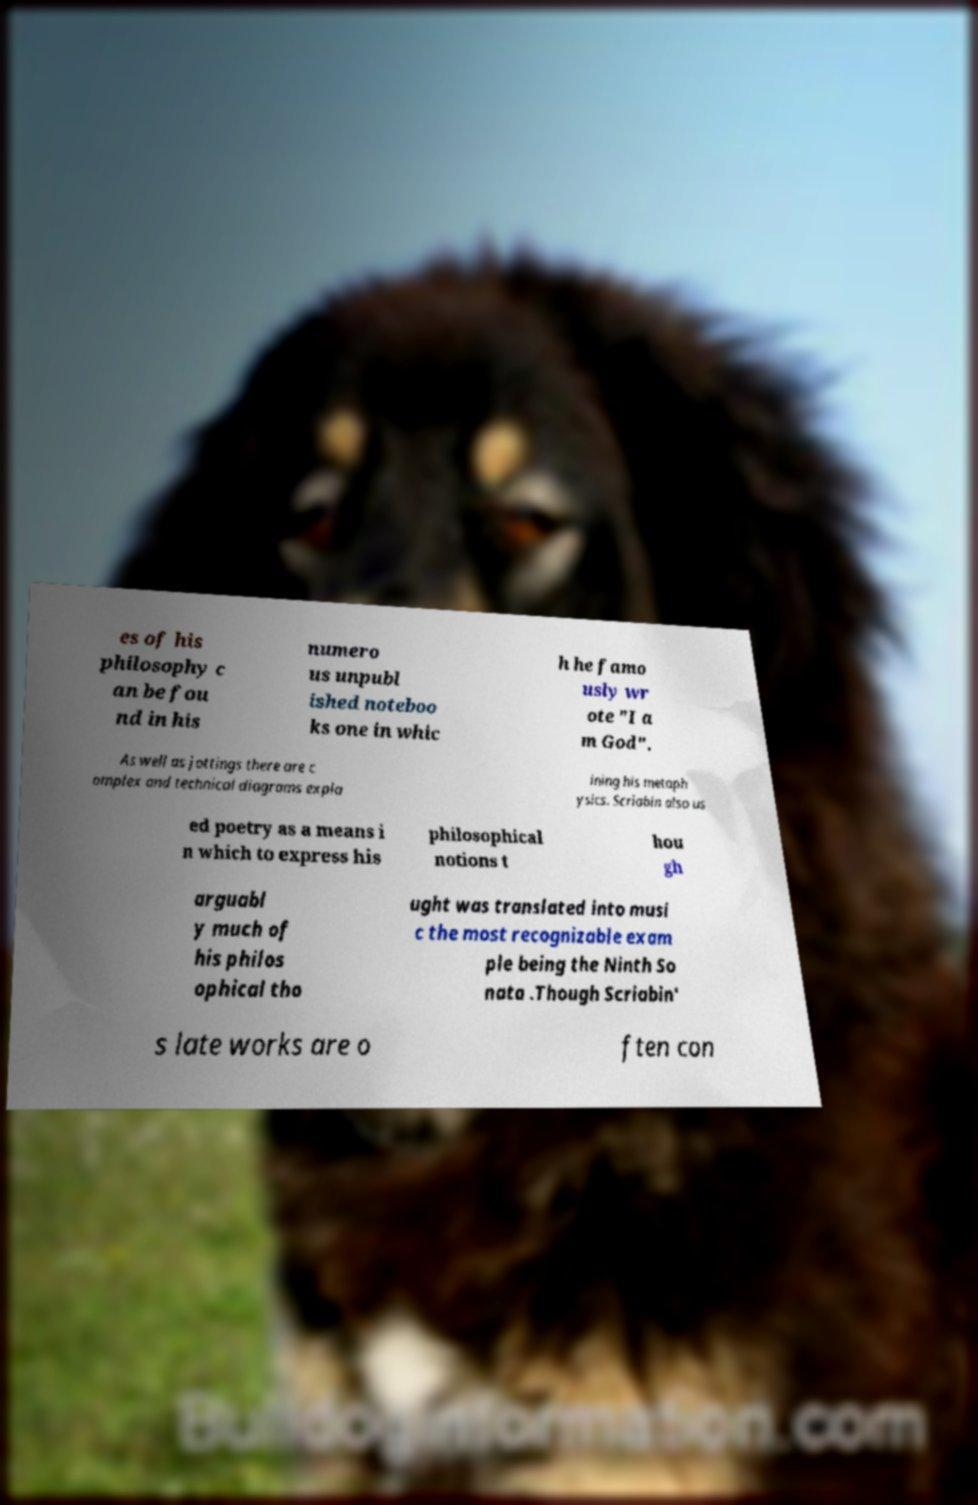I need the written content from this picture converted into text. Can you do that? es of his philosophy c an be fou nd in his numero us unpubl ished noteboo ks one in whic h he famo usly wr ote "I a m God". As well as jottings there are c omplex and technical diagrams expla ining his metaph ysics. Scriabin also us ed poetry as a means i n which to express his philosophical notions t hou gh arguabl y much of his philos ophical tho ught was translated into musi c the most recognizable exam ple being the Ninth So nata .Though Scriabin' s late works are o ften con 